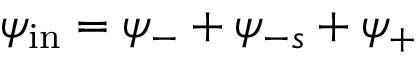Convert formula to latex. <formula><loc_0><loc_0><loc_500><loc_500>\psi _ { i n } = \psi _ { - } + \psi _ { - s } + \psi _ { + }</formula> 